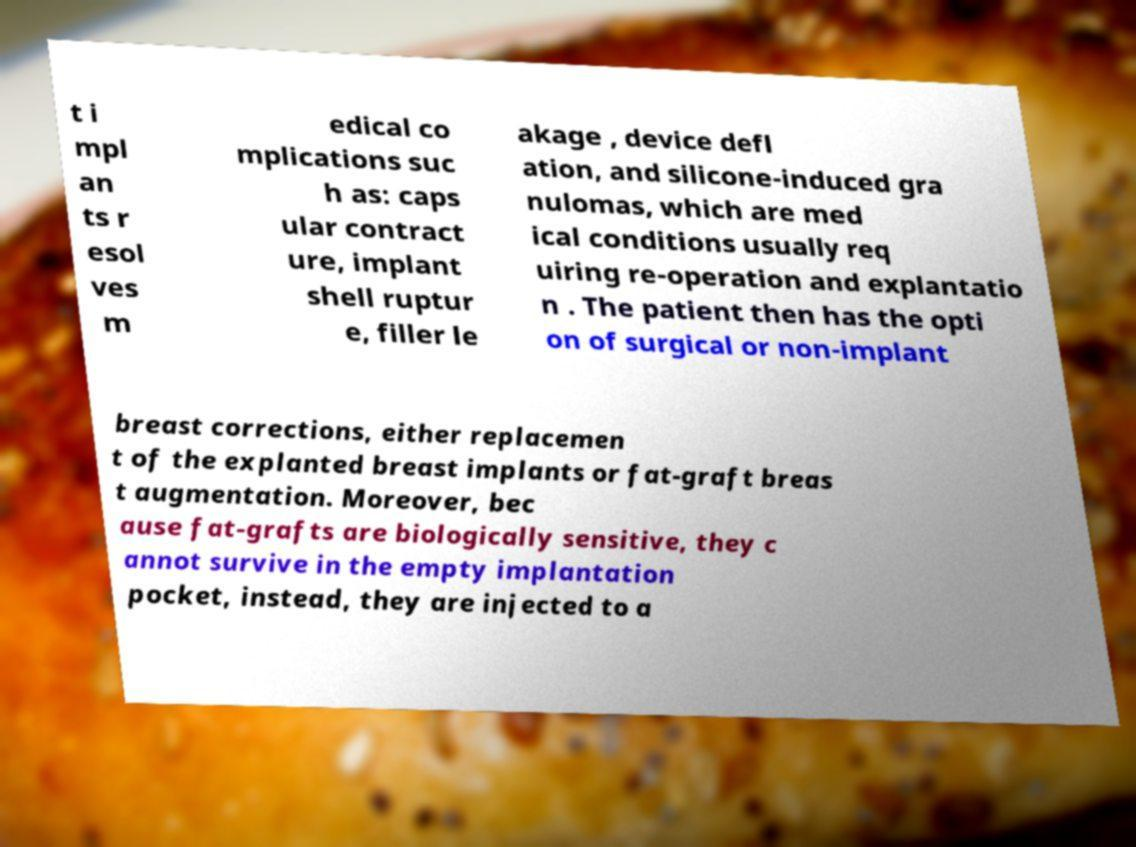Could you assist in decoding the text presented in this image and type it out clearly? t i mpl an ts r esol ves m edical co mplications suc h as: caps ular contract ure, implant shell ruptur e, filler le akage , device defl ation, and silicone-induced gra nulomas, which are med ical conditions usually req uiring re-operation and explantatio n . The patient then has the opti on of surgical or non-implant breast corrections, either replacemen t of the explanted breast implants or fat-graft breas t augmentation. Moreover, bec ause fat-grafts are biologically sensitive, they c annot survive in the empty implantation pocket, instead, they are injected to a 